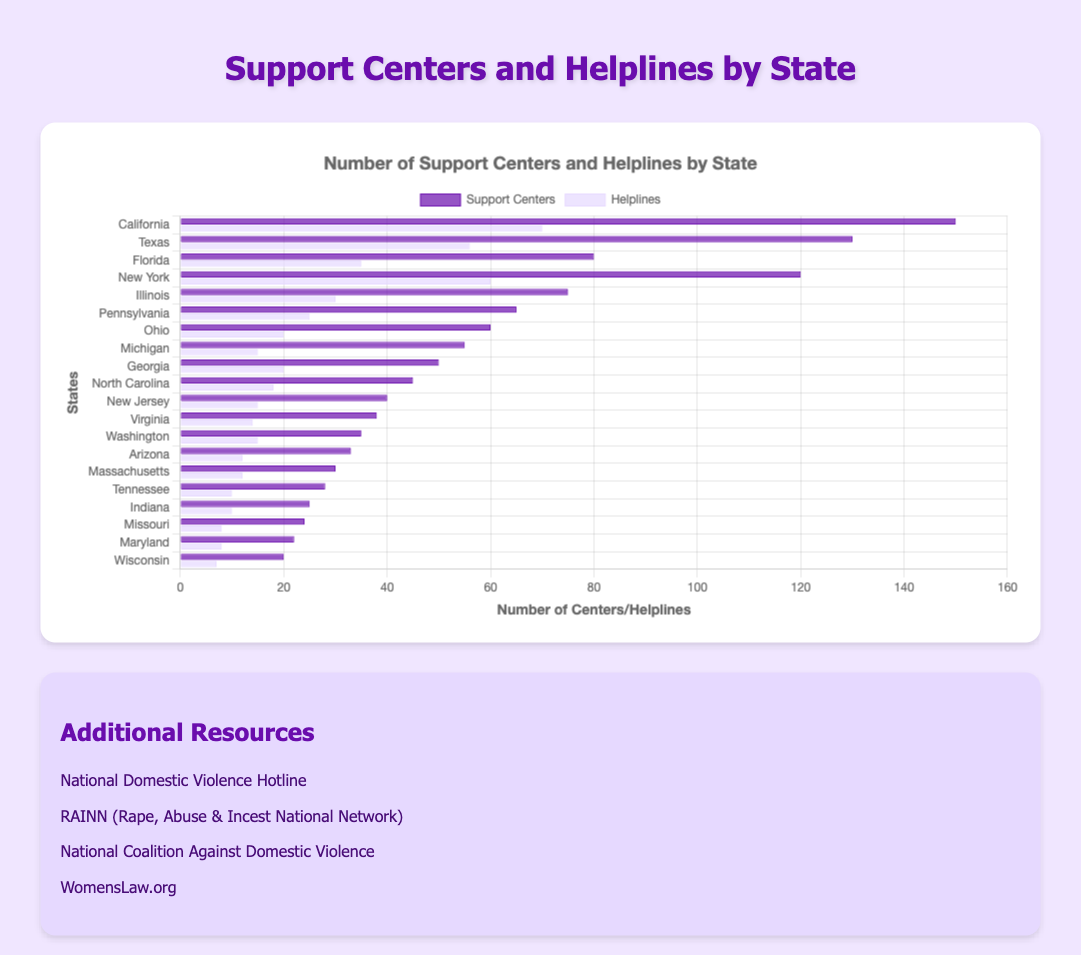Which state has the highest number of support centers? By looking at the horizontal bars on the left labeled "Support Centers," we can see that the longest bar corresponds to California.
Answer: California Which state has more helplines, New York or Texas? Compare the lengths of the horizontal bars for helplines between New York and Texas. New York's bar for helplines is longer than Texas's.
Answer: New York What is the total number of support centers in Florida and Illinois combined? Florida has 80 support centers and Illinois has 75 support centers. Adding them together gives 80 + 75 = 155.
Answer: 155 Which state has the smallest number of helplines? By looking at the shortest bar labeled "Helplines," we find that Wisconsin has the smallest number with just 7 helplines.
Answer: Wisconsin How many more support centers does California have compared to Georgia? California has 150 support centers and Georgia has 50 support centers. The difference is 150 - 50 = 100.
Answer: 100 Which state has more helplines: Michigan or Washington? Compare the lengths of the horizontal bars for helplines between Michigan and Washington. Both states have the same length of bars indicating they each have 15 helplines.
Answer: They are equal What is the average number of support centers in the five states with the highest counts? Identify the five states with the tallest bars for support centers: California (150), Texas (130), New York (120), Florida (80), and Illinois (75). Sum the support centers and find the average: (150 + 130 + 120 + 80 + 75) / 5 = 555 / 5 = 111.
Answer: 111 What is the difference in the number of helplines between Pennsylvania and Virginia? Pennsylvania has 25 helplines and Virginia has 14 helplines. The difference is 25 - 14 = 11.
Answer: 11 How many states have more than 50 support centers? Count the number of states where the horizontal bar for support centers exceeds 50. These states are California (150), Texas (130), New York (120), Florida (80), Illinois (75), and Ohio (60). There are 6 states in total.
Answer: 6 